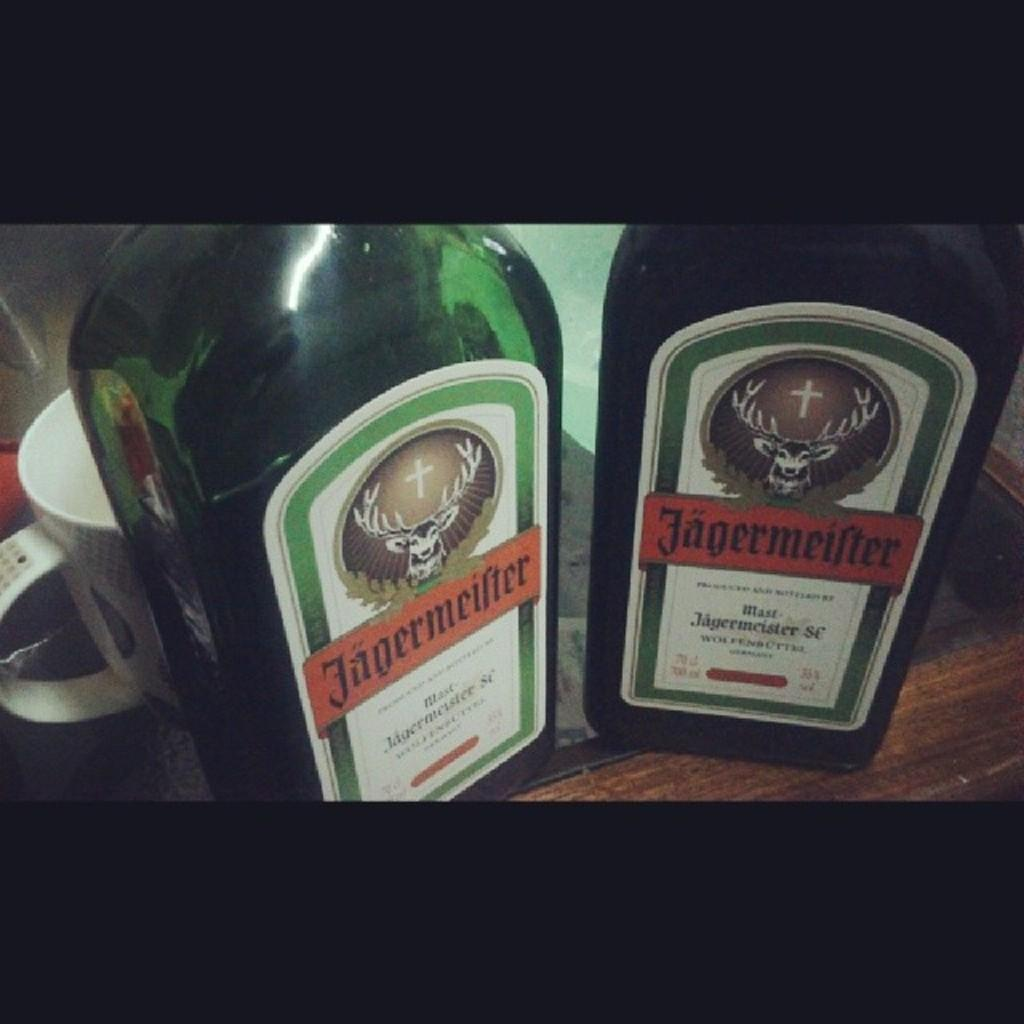<image>
Offer a succinct explanation of the picture presented. Two bottles of Jagermeister next to each other in front of a mug. 